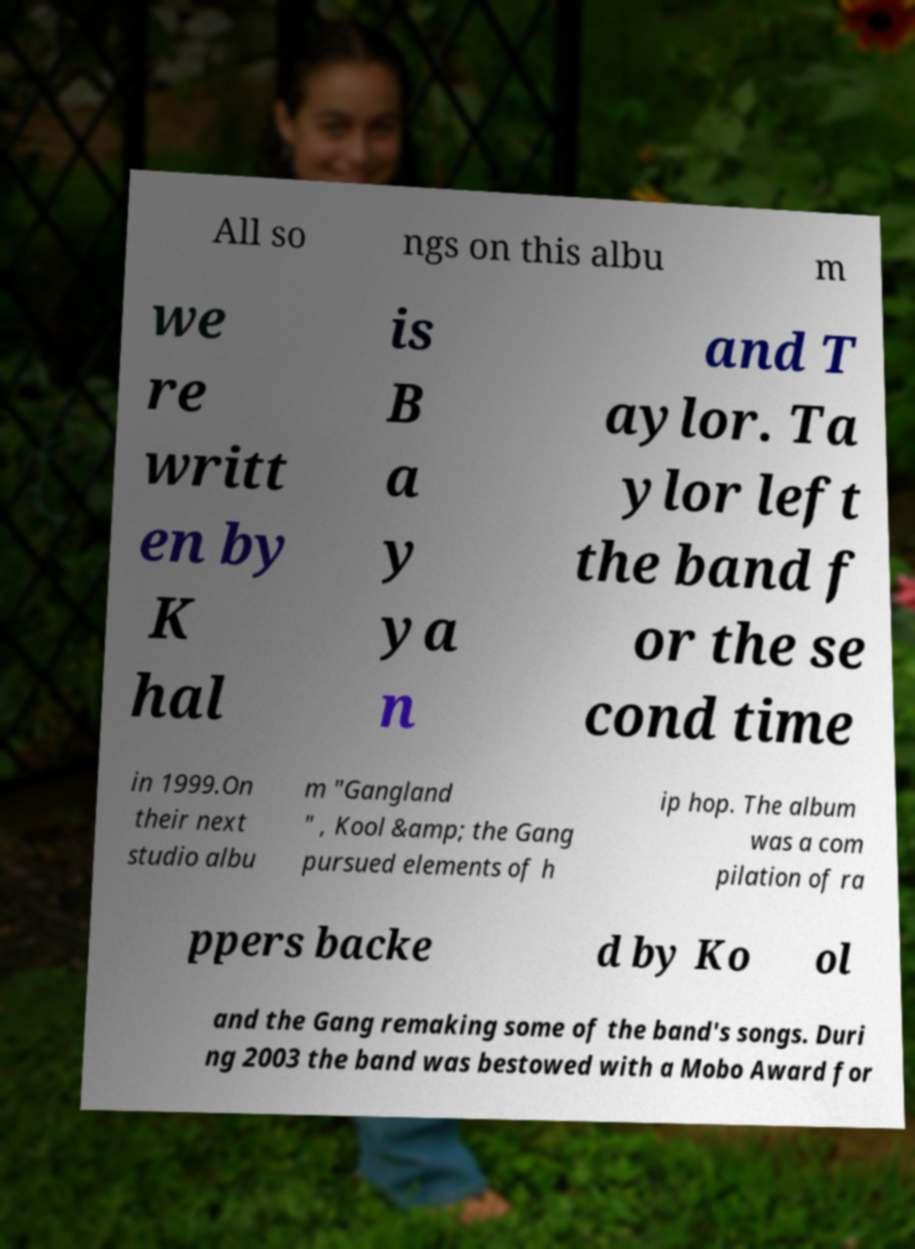I need the written content from this picture converted into text. Can you do that? All so ngs on this albu m we re writt en by K hal is B a y ya n and T aylor. Ta ylor left the band f or the se cond time in 1999.On their next studio albu m "Gangland " , Kool &amp; the Gang pursued elements of h ip hop. The album was a com pilation of ra ppers backe d by Ko ol and the Gang remaking some of the band's songs. Duri ng 2003 the band was bestowed with a Mobo Award for 